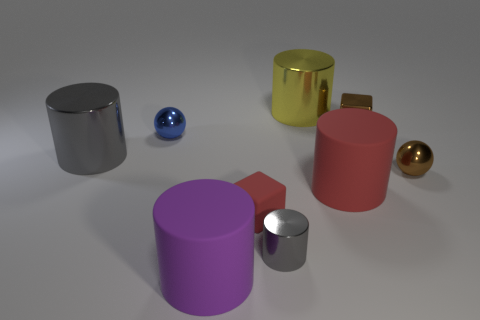Subtract all red cylinders. How many cylinders are left? 4 Subtract all balls. How many objects are left? 7 Subtract 5 cylinders. How many cylinders are left? 0 Subtract all purple cylinders. Subtract all gray balls. How many cylinders are left? 4 Subtract all blue spheres. How many red blocks are left? 1 Subtract all red blocks. How many blocks are left? 1 Subtract all tiny rubber blocks. Subtract all small red rubber cubes. How many objects are left? 7 Add 3 brown spheres. How many brown spheres are left? 4 Add 4 red matte cylinders. How many red matte cylinders exist? 5 Subtract 0 yellow blocks. How many objects are left? 9 